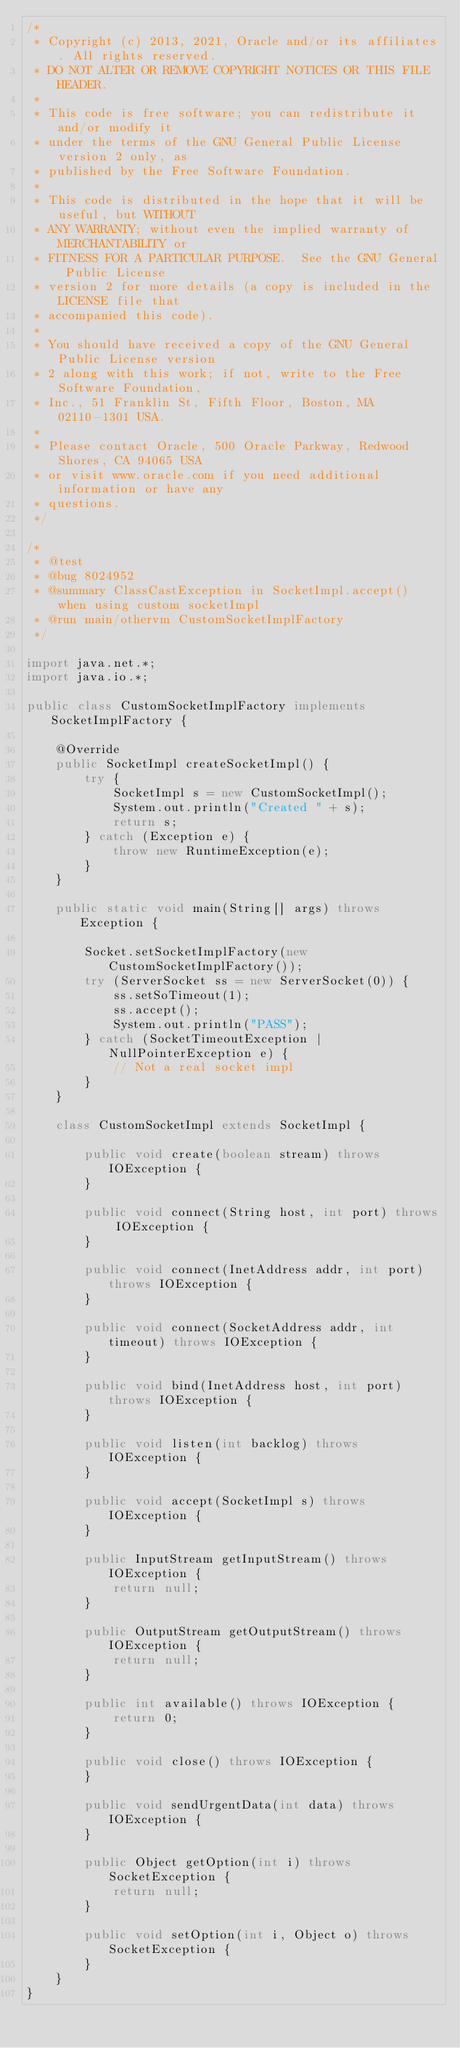<code> <loc_0><loc_0><loc_500><loc_500><_Java_>/*
 * Copyright (c) 2013, 2021, Oracle and/or its affiliates. All rights reserved.
 * DO NOT ALTER OR REMOVE COPYRIGHT NOTICES OR THIS FILE HEADER.
 *
 * This code is free software; you can redistribute it and/or modify it
 * under the terms of the GNU General Public License version 2 only, as
 * published by the Free Software Foundation.
 *
 * This code is distributed in the hope that it will be useful, but WITHOUT
 * ANY WARRANTY; without even the implied warranty of MERCHANTABILITY or
 * FITNESS FOR A PARTICULAR PURPOSE.  See the GNU General Public License
 * version 2 for more details (a copy is included in the LICENSE file that
 * accompanied this code).
 *
 * You should have received a copy of the GNU General Public License version
 * 2 along with this work; if not, write to the Free Software Foundation,
 * Inc., 51 Franklin St, Fifth Floor, Boston, MA 02110-1301 USA.
 *
 * Please contact Oracle, 500 Oracle Parkway, Redwood Shores, CA 94065 USA
 * or visit www.oracle.com if you need additional information or have any
 * questions.
 */

/*
 * @test
 * @bug 8024952
 * @summary ClassCastException in SocketImpl.accept() when using custom socketImpl
 * @run main/othervm CustomSocketImplFactory
 */

import java.net.*;
import java.io.*;

public class CustomSocketImplFactory implements SocketImplFactory {

    @Override
    public SocketImpl createSocketImpl() {
        try {
            SocketImpl s = new CustomSocketImpl();
            System.out.println("Created " + s);
            return s;
        } catch (Exception e) {
            throw new RuntimeException(e);
        }
    }

    public static void main(String[] args) throws Exception {

        Socket.setSocketImplFactory(new CustomSocketImplFactory());
        try (ServerSocket ss = new ServerSocket(0)) {
            ss.setSoTimeout(1);
            ss.accept();
            System.out.println("PASS");
        } catch (SocketTimeoutException | NullPointerException e) {
            // Not a real socket impl
        }
    }

    class CustomSocketImpl extends SocketImpl {

        public void create(boolean stream) throws IOException {
        }

        public void connect(String host, int port) throws IOException {
        }

        public void connect(InetAddress addr, int port) throws IOException {
        }

        public void connect(SocketAddress addr, int timeout) throws IOException {
        }

        public void bind(InetAddress host, int port) throws IOException {
        }

        public void listen(int backlog) throws IOException {
        }

        public void accept(SocketImpl s) throws IOException {
        }

        public InputStream getInputStream() throws IOException {
            return null;
        }

        public OutputStream getOutputStream() throws IOException {
            return null;
        }

        public int available() throws IOException {
            return 0;
        }

        public void close() throws IOException {
        }

        public void sendUrgentData(int data) throws IOException {
        }

        public Object getOption(int i) throws SocketException {
            return null;
        }

        public void setOption(int i, Object o) throws SocketException {
        }
    }
}
</code> 